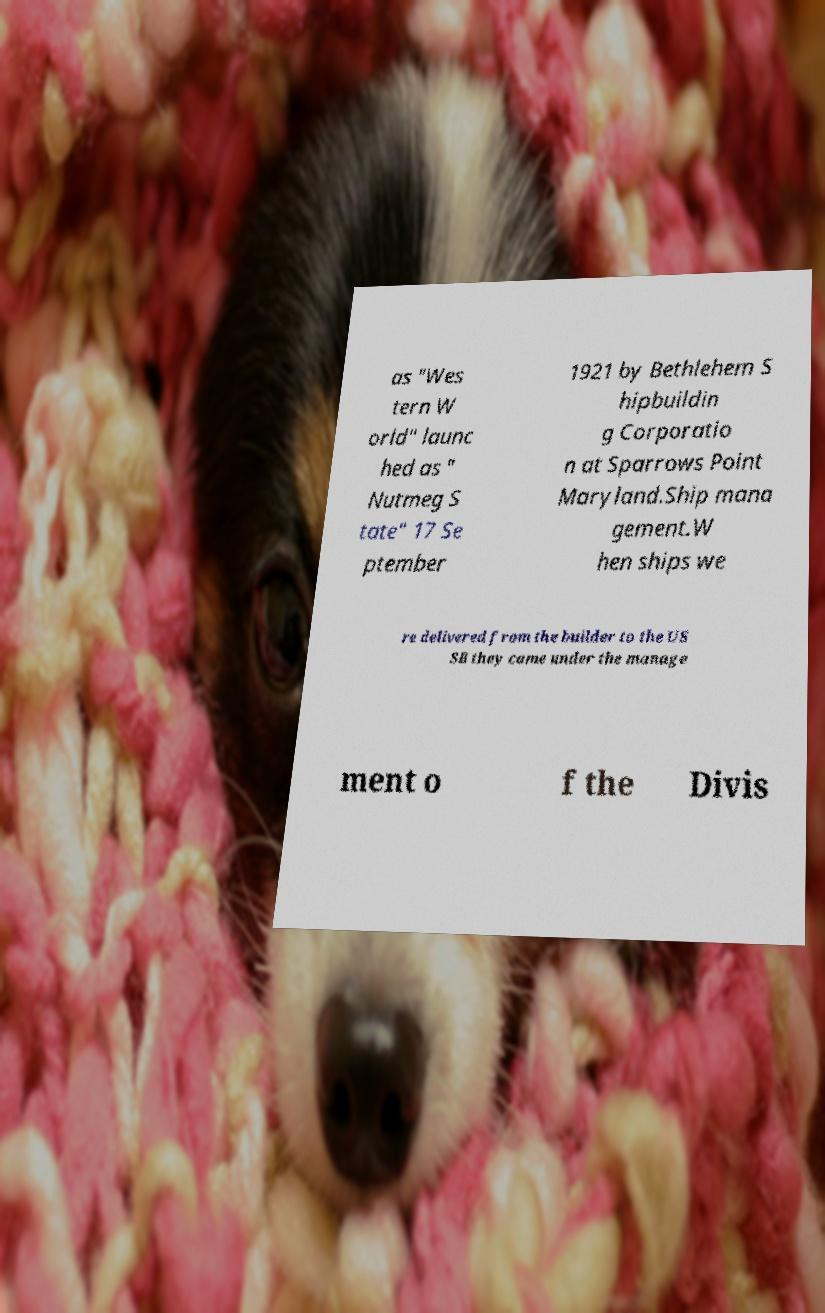I need the written content from this picture converted into text. Can you do that? as "Wes tern W orld" launc hed as " Nutmeg S tate" 17 Se ptember 1921 by Bethlehem S hipbuildin g Corporatio n at Sparrows Point Maryland.Ship mana gement.W hen ships we re delivered from the builder to the US SB they came under the manage ment o f the Divis 